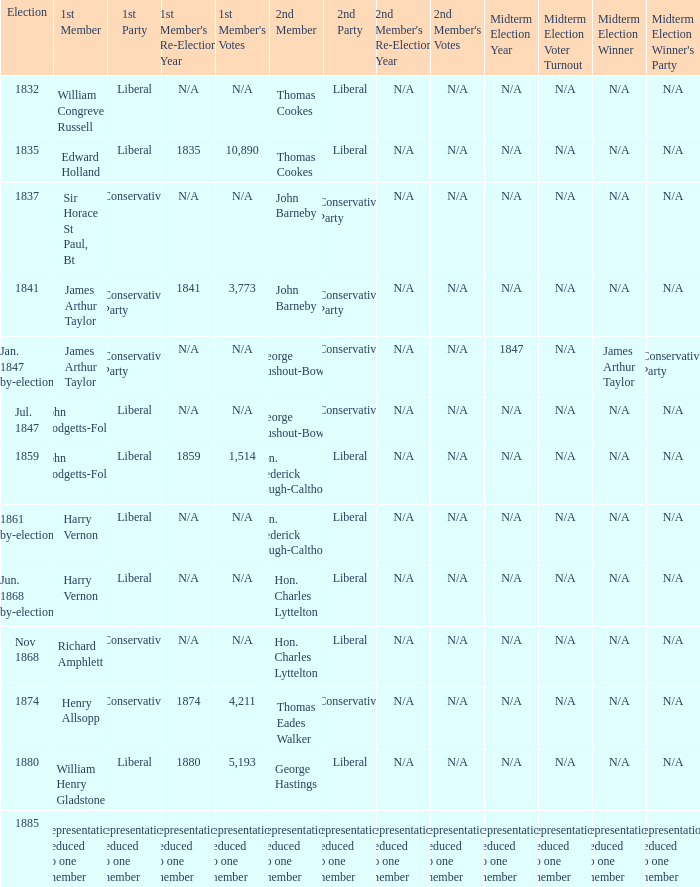What was the 2nd Party, when the 1st Member was John Hodgetts-Foley, and the 2nd Member was Hon. Frederick Gough-Calthorpe? Liberal. Could you parse the entire table? {'header': ['Election', '1st Member', '1st Party', "1st Member's Re-Election Year", "1st Member's Votes", '2nd Member', '2nd Party', "2nd Member's Re-Election Year", "2nd Member's Votes", 'Midterm Election Year', 'Midterm Election Voter Turnout', 'Midterm Election Winner', "Midterm Election Winner's Party"], 'rows': [['1832', 'William Congreve Russell', 'Liberal', 'N/A', 'N/A', 'Thomas Cookes', 'Liberal', 'N/A', 'N/A', 'N/A', 'N/A', 'N/A', 'N/A'], ['1835', 'Edward Holland', 'Liberal', '1835', '10,890', 'Thomas Cookes', 'Liberal', 'N/A', 'N/A', 'N/A', 'N/A', 'N/A', 'N/A'], ['1837', 'Sir Horace St Paul, Bt', 'Conservative', 'N/A', 'N/A', 'John Barneby', 'Conservative Party', 'N/A', 'N/A', 'N/A', 'N/A', 'N/A', 'N/A'], ['1841', 'James Arthur Taylor', 'Conservative Party', '1841', '3,773', 'John Barneby', 'Conservative Party', 'N/A', 'N/A', 'N/A', 'N/A', 'N/A', 'N/A'], ['Jan. 1847 by-election', 'James Arthur Taylor', 'Conservative Party', 'N/A', 'N/A', 'George Rushout-Bowes', 'Conservative', 'N/A', 'N/A', '1847', 'N/A', 'James Arthur Taylor', 'Conservative Party'], ['Jul. 1847', 'John Hodgetts-Foley', 'Liberal', 'N/A', 'N/A', 'George Rushout-Bowes', 'Conservative', 'N/A', 'N/A', 'N/A', 'N/A', 'N/A', 'N/A'], ['1859', 'John Hodgetts-Foley', 'Liberal', '1859', '1,514', 'Hon. Frederick Gough-Calthorpe', 'Liberal', 'N/A', 'N/A', 'N/A', 'N/A', 'N/A', 'N/A'], ['1861 by-election', 'Harry Vernon', 'Liberal', 'N/A', 'N/A', 'Hon. Frederick Gough-Calthorpe', 'Liberal', 'N/A', 'N/A', 'N/A', 'N/A', 'N/A', 'N/A'], ['Jun. 1868 by-election', 'Harry Vernon', 'Liberal', 'N/A', 'N/A', 'Hon. Charles Lyttelton', 'Liberal', 'N/A', 'N/A', 'N/A', 'N/A', 'N/A', 'N/A'], ['Nov 1868', 'Richard Amphlett', 'Conservative', 'N/A', 'N/A', 'Hon. Charles Lyttelton', 'Liberal', 'N/A', 'N/A', 'N/A', 'N/A', 'N/A', 'N/A'], ['1874', 'Henry Allsopp', 'Conservative', '1874', '4,211', 'Thomas Eades Walker', 'Conservative', 'N/A', 'N/A', 'N/A', 'N/A', 'N/A', 'N/A'], ['1880', 'William Henry Gladstone', 'Liberal', '1880', '5,193', 'George Hastings', 'Liberal', 'N/A', 'N/A', 'N/A', 'N/A', 'N/A', 'N/A'], ['1885', 'representation reduced to one member', 'representation reduced to one member', 'representation reduced to one member', 'representation reduced to one member', 'representation reduced to one member', 'representation reduced to one member', 'representation reduced to one member', 'representation reduced to one member', 'representation reduced to one member', 'representation reduced to one member', 'representation reduced to one member', 'representation reduced to one member']]} 